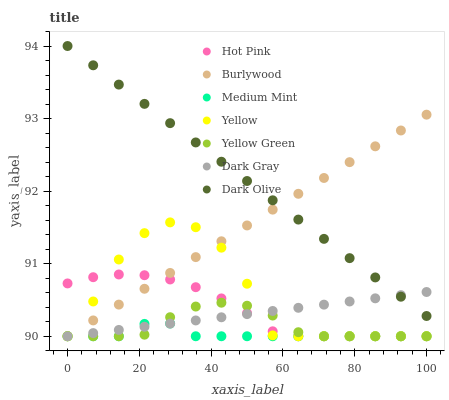Does Medium Mint have the minimum area under the curve?
Answer yes or no. Yes. Does Dark Olive have the maximum area under the curve?
Answer yes or no. Yes. Does Yellow Green have the minimum area under the curve?
Answer yes or no. No. Does Yellow Green have the maximum area under the curve?
Answer yes or no. No. Is Dark Gray the smoothest?
Answer yes or no. Yes. Is Yellow the roughest?
Answer yes or no. Yes. Is Dark Olive the smoothest?
Answer yes or no. No. Is Dark Olive the roughest?
Answer yes or no. No. Does Medium Mint have the lowest value?
Answer yes or no. Yes. Does Dark Olive have the lowest value?
Answer yes or no. No. Does Dark Olive have the highest value?
Answer yes or no. Yes. Does Yellow Green have the highest value?
Answer yes or no. No. Is Medium Mint less than Dark Olive?
Answer yes or no. Yes. Is Dark Olive greater than Yellow Green?
Answer yes or no. Yes. Does Hot Pink intersect Medium Mint?
Answer yes or no. Yes. Is Hot Pink less than Medium Mint?
Answer yes or no. No. Is Hot Pink greater than Medium Mint?
Answer yes or no. No. Does Medium Mint intersect Dark Olive?
Answer yes or no. No. 